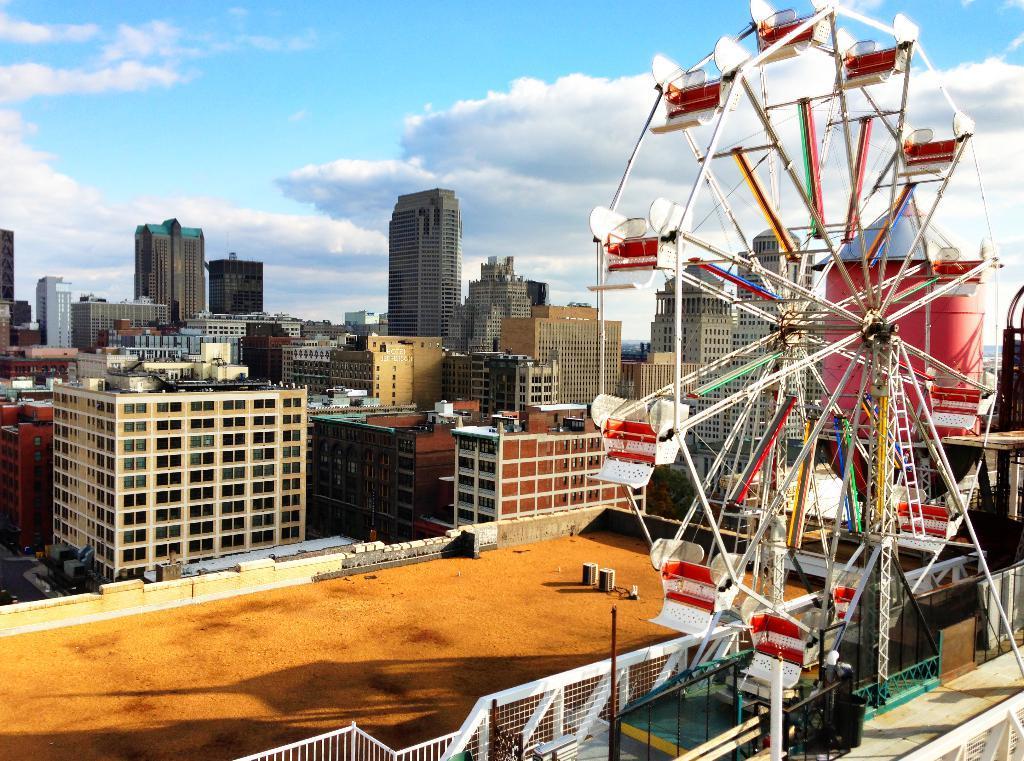In one or two sentences, can you explain what this image depicts? In this image we can see a group of buildings. At the top we can see the sky. On the right side, we can see a giant wheel. At the bottom we can see a metal fence. 